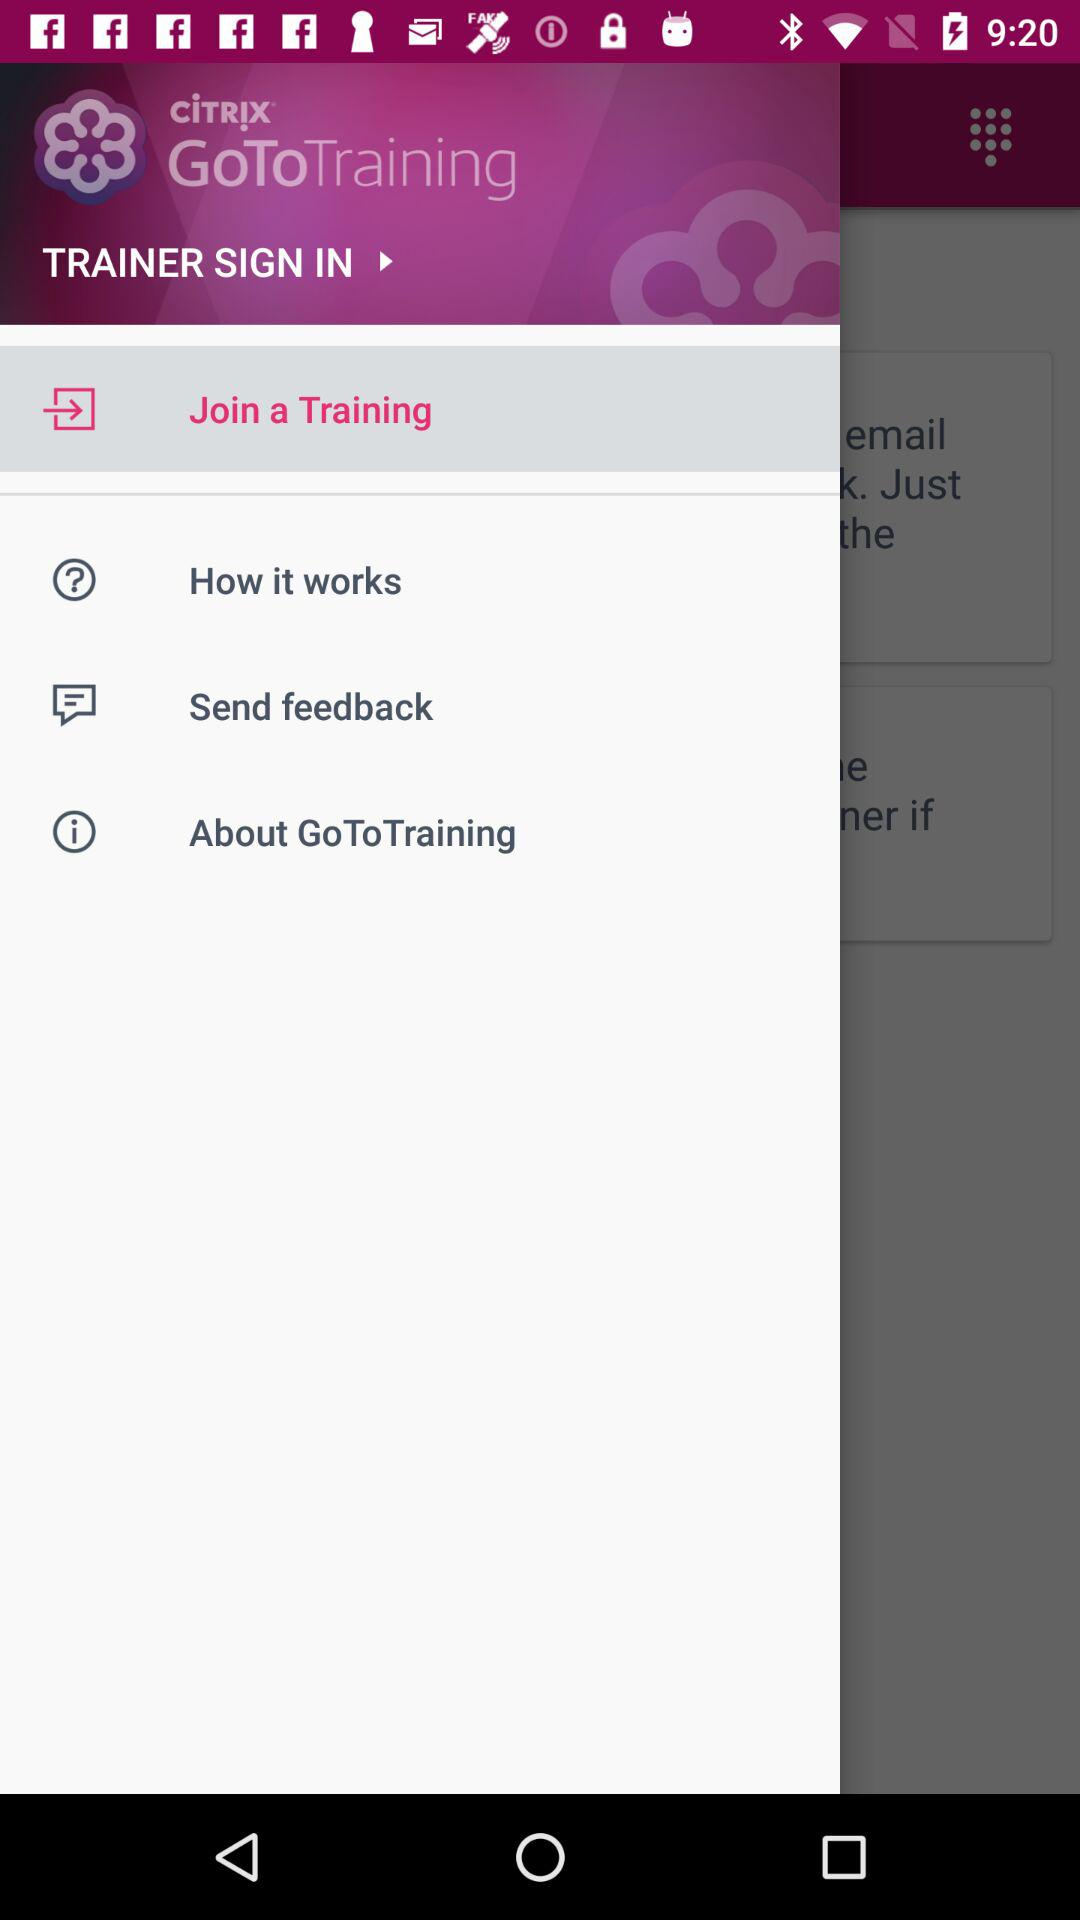What is the name of the application? The name of the application is "GoToTraining". 